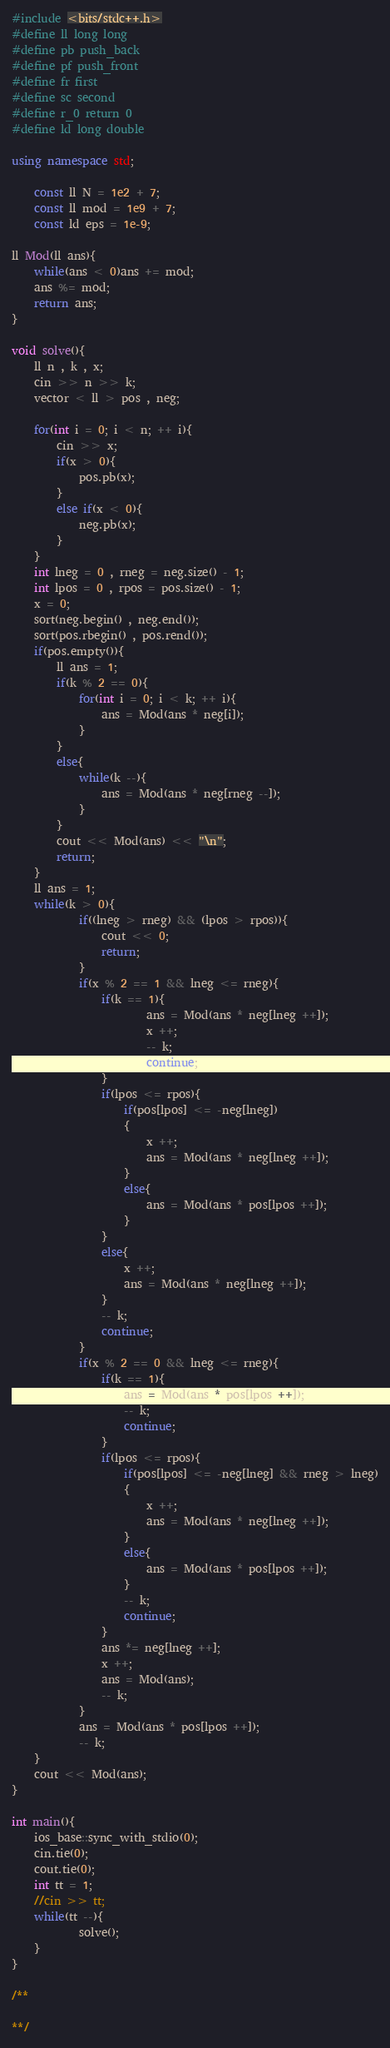Convert code to text. <code><loc_0><loc_0><loc_500><loc_500><_C++_>#include <bits/stdc++.h>
#define ll long long
#define pb push_back
#define pf push_front
#define fr first
#define sc second
#define r_0 return 0
#define ld long double

using namespace std;

    const ll N = 1e2 + 7;
    const ll mod = 1e9 + 7;
    const ld eps = 1e-9;

ll Mod(ll ans){
    while(ans < 0)ans += mod;
    ans %= mod;
    return ans;
}

void solve(){
    ll n , k , x;
    cin >> n >> k;
    vector < ll > pos , neg;

    for(int i = 0; i < n; ++ i){
        cin >> x;
        if(x > 0){
            pos.pb(x);
        }
        else if(x < 0){
            neg.pb(x);
        }
    }
    int lneg = 0 , rneg = neg.size() - 1;
    int lpos = 0 , rpos = pos.size() - 1;
    x = 0;
    sort(neg.begin() , neg.end());
    sort(pos.rbegin() , pos.rend());
    if(pos.empty()){
        ll ans = 1;
        if(k % 2 == 0){
            for(int i = 0; i < k; ++ i){
                ans = Mod(ans * neg[i]);
            }
        }
        else{
            while(k --){
                ans = Mod(ans * neg[rneg --]);
            }
        }
        cout << Mod(ans) << "\n";
        return;
    }
    ll ans = 1;
    while(k > 0){
            if((lneg > rneg) && (lpos > rpos)){
                cout << 0;
                return;
            }
            if(x % 2 == 1 && lneg <= rneg){
                if(k == 1){
                        ans = Mod(ans * neg[lneg ++]);
                        x ++;
                        -- k;
                        continue;
                }
                if(lpos <= rpos){
                    if(pos[lpos] <= -neg[lneg])
                    {
                        x ++;
                        ans = Mod(ans * neg[lneg ++]);
                    }
                    else{
                        ans = Mod(ans * pos[lpos ++]);
                    }
                }
                else{
                    x ++;
                    ans = Mod(ans * neg[lneg ++]);
                }
                -- k;
                continue;
            }
            if(x % 2 == 0 && lneg <= rneg){
                if(k == 1){
                    ans = Mod(ans * pos[lpos ++]);
                    -- k;
                    continue;
                }
                if(lpos <= rpos){
                    if(pos[lpos] <= -neg[lneg] && rneg > lneg)
                    {
                        x ++;
                        ans = Mod(ans * neg[lneg ++]);
                    }
                    else{
                        ans = Mod(ans * pos[lpos ++]);
                    }
                    -- k;
                    continue;
                }
                ans *= neg[lneg ++];
                x ++;
                ans = Mod(ans);
                -- k;
            }
            ans = Mod(ans * pos[lpos ++]);
            -- k;
    }
    cout << Mod(ans);
}

int main(){
    ios_base::sync_with_stdio(0);
    cin.tie(0);
    cout.tie(0);
    int tt = 1;
    //cin >> tt;
    while(tt --){
            solve();
    }
}

/**

**/
</code> 